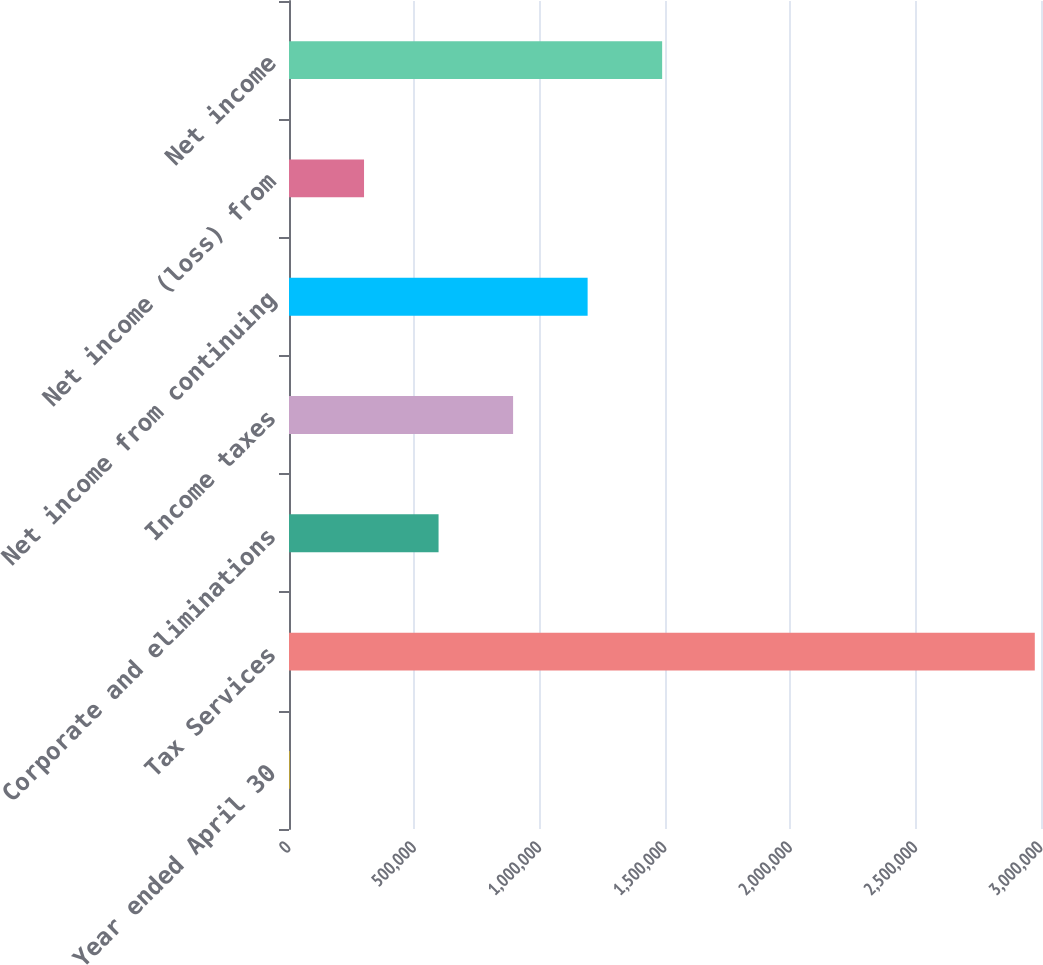<chart> <loc_0><loc_0><loc_500><loc_500><bar_chart><fcel>Year ended April 30<fcel>Tax Services<fcel>Corporate and eliminations<fcel>Income taxes<fcel>Net income from continuing<fcel>Net income (loss) from<fcel>Net income<nl><fcel>2010<fcel>2.97525e+06<fcel>596658<fcel>893983<fcel>1.19131e+06<fcel>299334<fcel>1.48863e+06<nl></chart> 